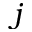<formula> <loc_0><loc_0><loc_500><loc_500>j</formula> 